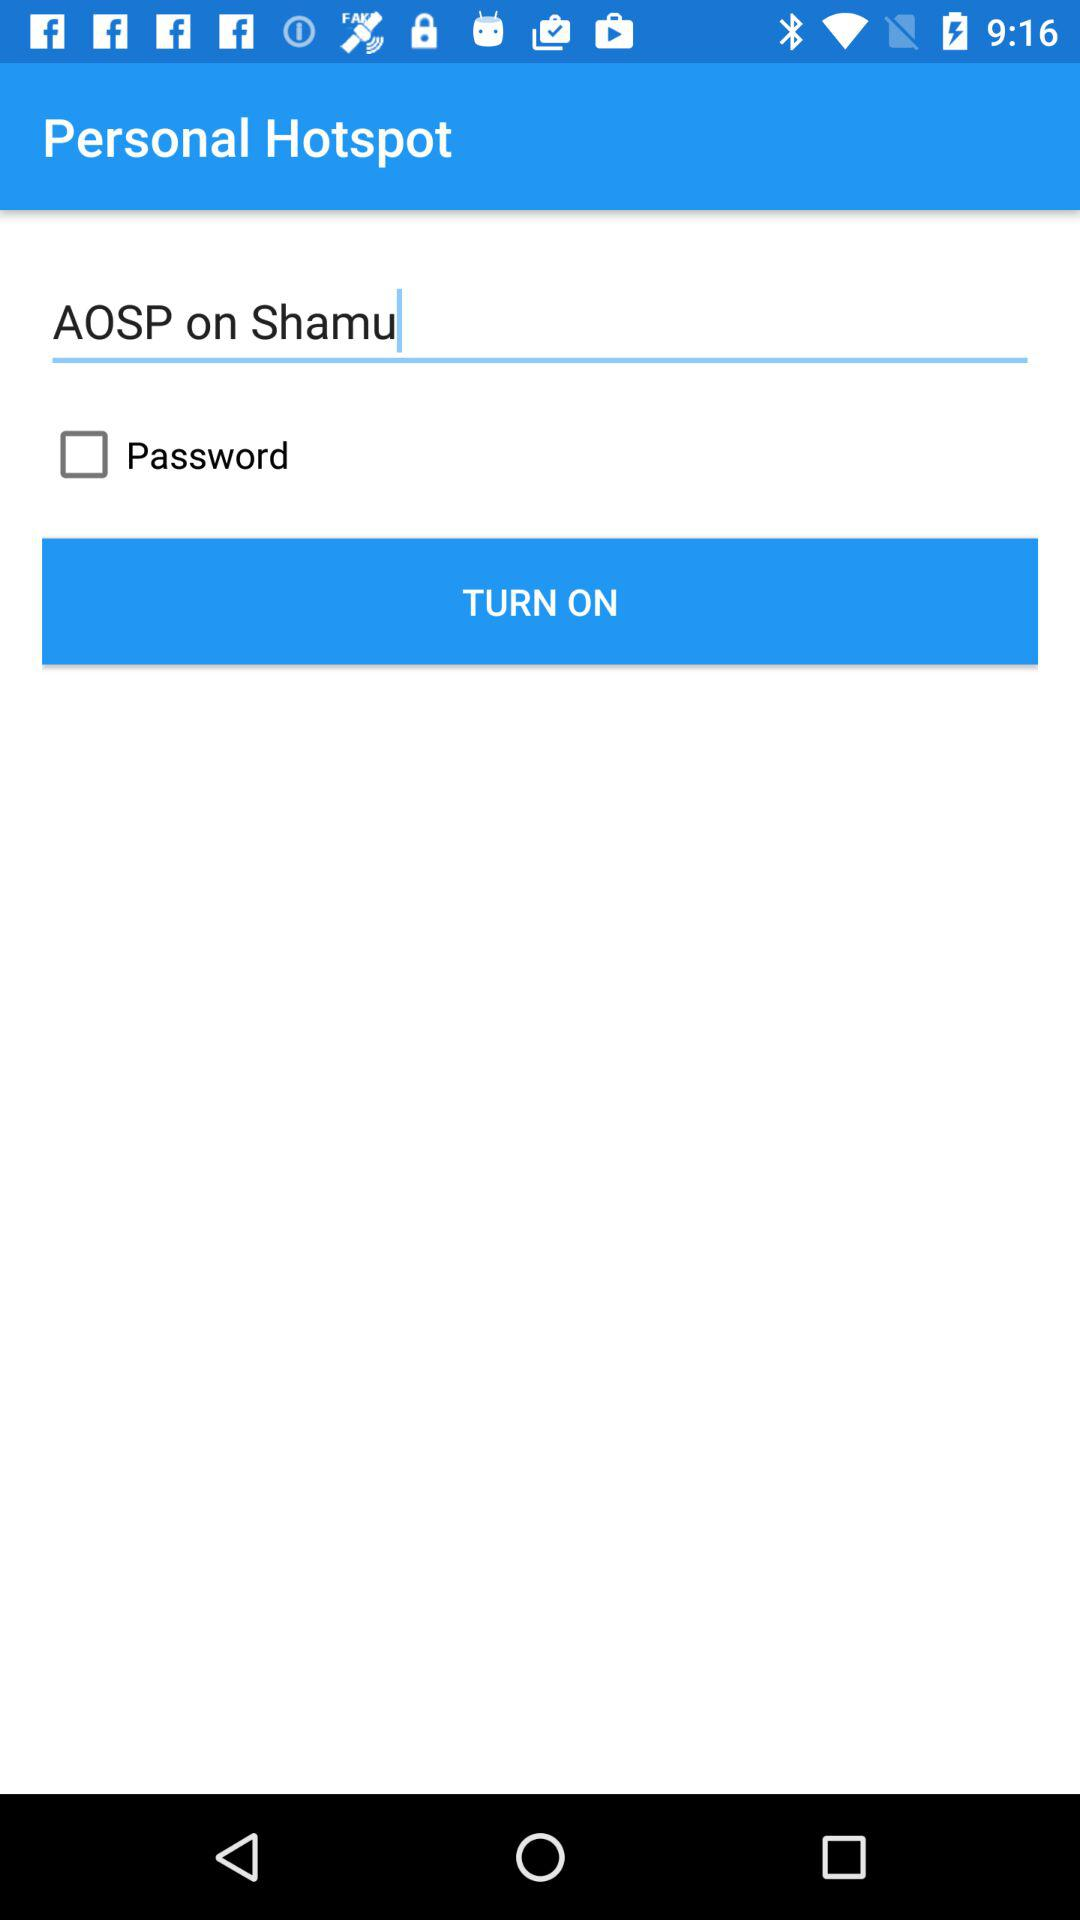What is the status of the "Password"? The status is "off". 